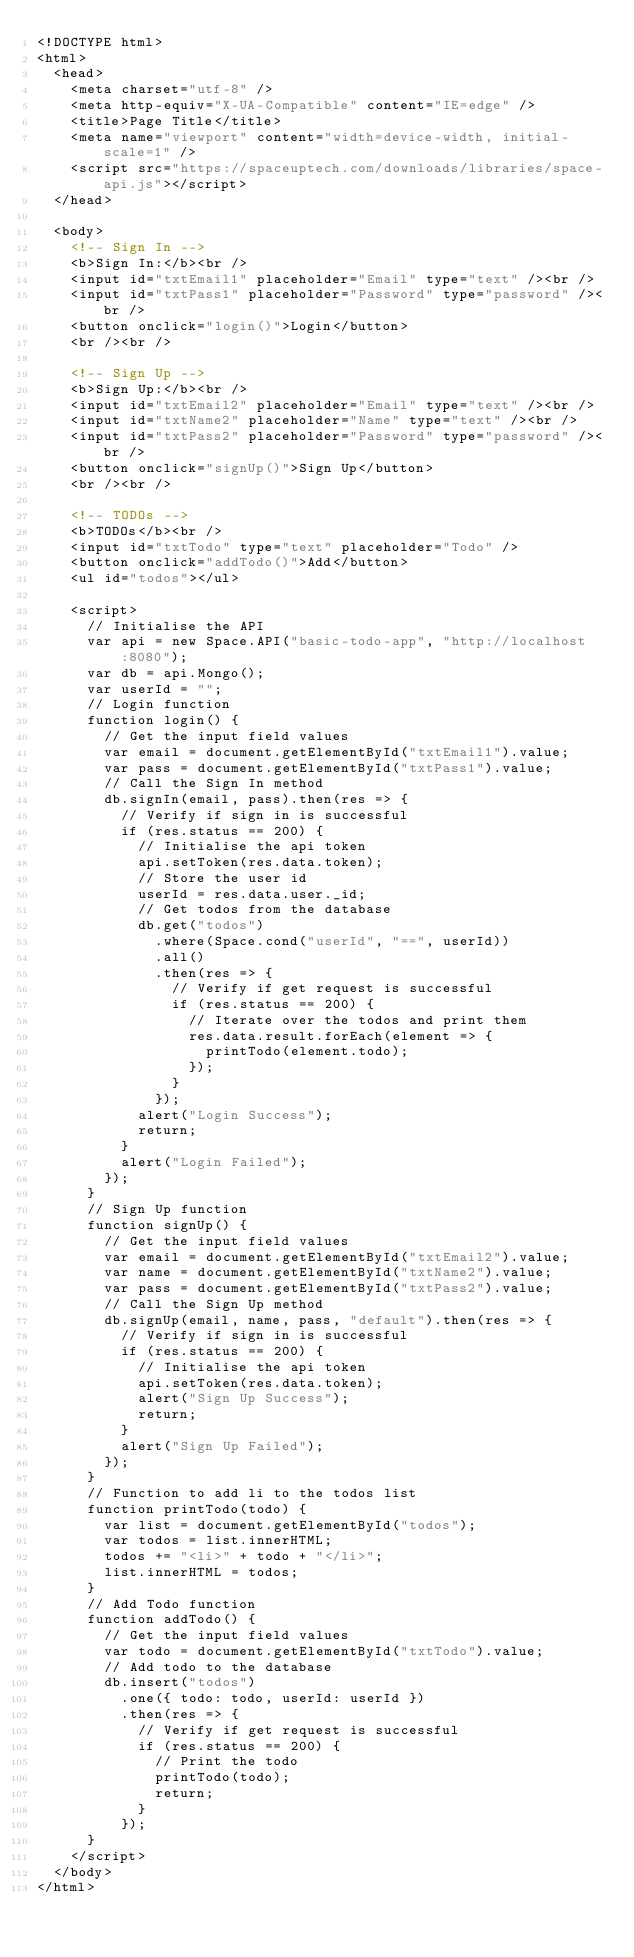<code> <loc_0><loc_0><loc_500><loc_500><_HTML_><!DOCTYPE html>
<html>
  <head>
    <meta charset="utf-8" />
    <meta http-equiv="X-UA-Compatible" content="IE=edge" />
    <title>Page Title</title>
    <meta name="viewport" content="width=device-width, initial-scale=1" />
    <script src="https://spaceuptech.com/downloads/libraries/space-api.js"></script>
  </head>

  <body>
    <!-- Sign In -->
    <b>Sign In:</b><br />
    <input id="txtEmail1" placeholder="Email" type="text" /><br />
    <input id="txtPass1" placeholder="Password" type="password" /><br />
    <button onclick="login()">Login</button>
    <br /><br />

    <!-- Sign Up -->
    <b>Sign Up:</b><br />
    <input id="txtEmail2" placeholder="Email" type="text" /><br />
    <input id="txtName2" placeholder="Name" type="text" /><br />
    <input id="txtPass2" placeholder="Password" type="password" /><br />
    <button onclick="signUp()">Sign Up</button>
    <br /><br />

    <!-- TODOs -->
    <b>TODOs</b><br />
    <input id="txtTodo" type="text" placeholder="Todo" />
    <button onclick="addTodo()">Add</button>
    <ul id="todos"></ul>

    <script>
      // Initialise the API
      var api = new Space.API("basic-todo-app", "http://localhost:8080");
      var db = api.Mongo();
      var userId = "";
      // Login function
      function login() {
        // Get the input field values
        var email = document.getElementById("txtEmail1").value;
        var pass = document.getElementById("txtPass1").value;
        // Call the Sign In method
        db.signIn(email, pass).then(res => {
          // Verify if sign in is successful
          if (res.status == 200) {
            // Initialise the api token
            api.setToken(res.data.token);
            // Store the user id
            userId = res.data.user._id;
            // Get todos from the database
            db.get("todos")
              .where(Space.cond("userId", "==", userId))
              .all()
              .then(res => {
                // Verify if get request is successful
                if (res.status == 200) {
                  // Iterate over the todos and print them
                  res.data.result.forEach(element => {
                    printTodo(element.todo);
                  });
                }
              });
            alert("Login Success");
            return;
          }
          alert("Login Failed");
        });
      }
      // Sign Up function
      function signUp() {
        // Get the input field values
        var email = document.getElementById("txtEmail2").value;
        var name = document.getElementById("txtName2").value;
        var pass = document.getElementById("txtPass2").value;
        // Call the Sign Up method
        db.signUp(email, name, pass, "default").then(res => {
          // Verify if sign in is successful
          if (res.status == 200) {
            // Initialise the api token
            api.setToken(res.data.token);
            alert("Sign Up Success");
            return;
          }
          alert("Sign Up Failed");
        });
      }
      // Function to add li to the todos list
      function printTodo(todo) {
        var list = document.getElementById("todos");
        var todos = list.innerHTML;
        todos += "<li>" + todo + "</li>";
        list.innerHTML = todos;
      }
      // Add Todo function
      function addTodo() {
        // Get the input field values
        var todo = document.getElementById("txtTodo").value;
        // Add todo to the database
        db.insert("todos")
          .one({ todo: todo, userId: userId })
          .then(res => {
            // Verify if get request is successful
            if (res.status == 200) {
              // Print the todo
              printTodo(todo);
              return;
            }
          });
      }
    </script>
  </body>
</html>
</code> 